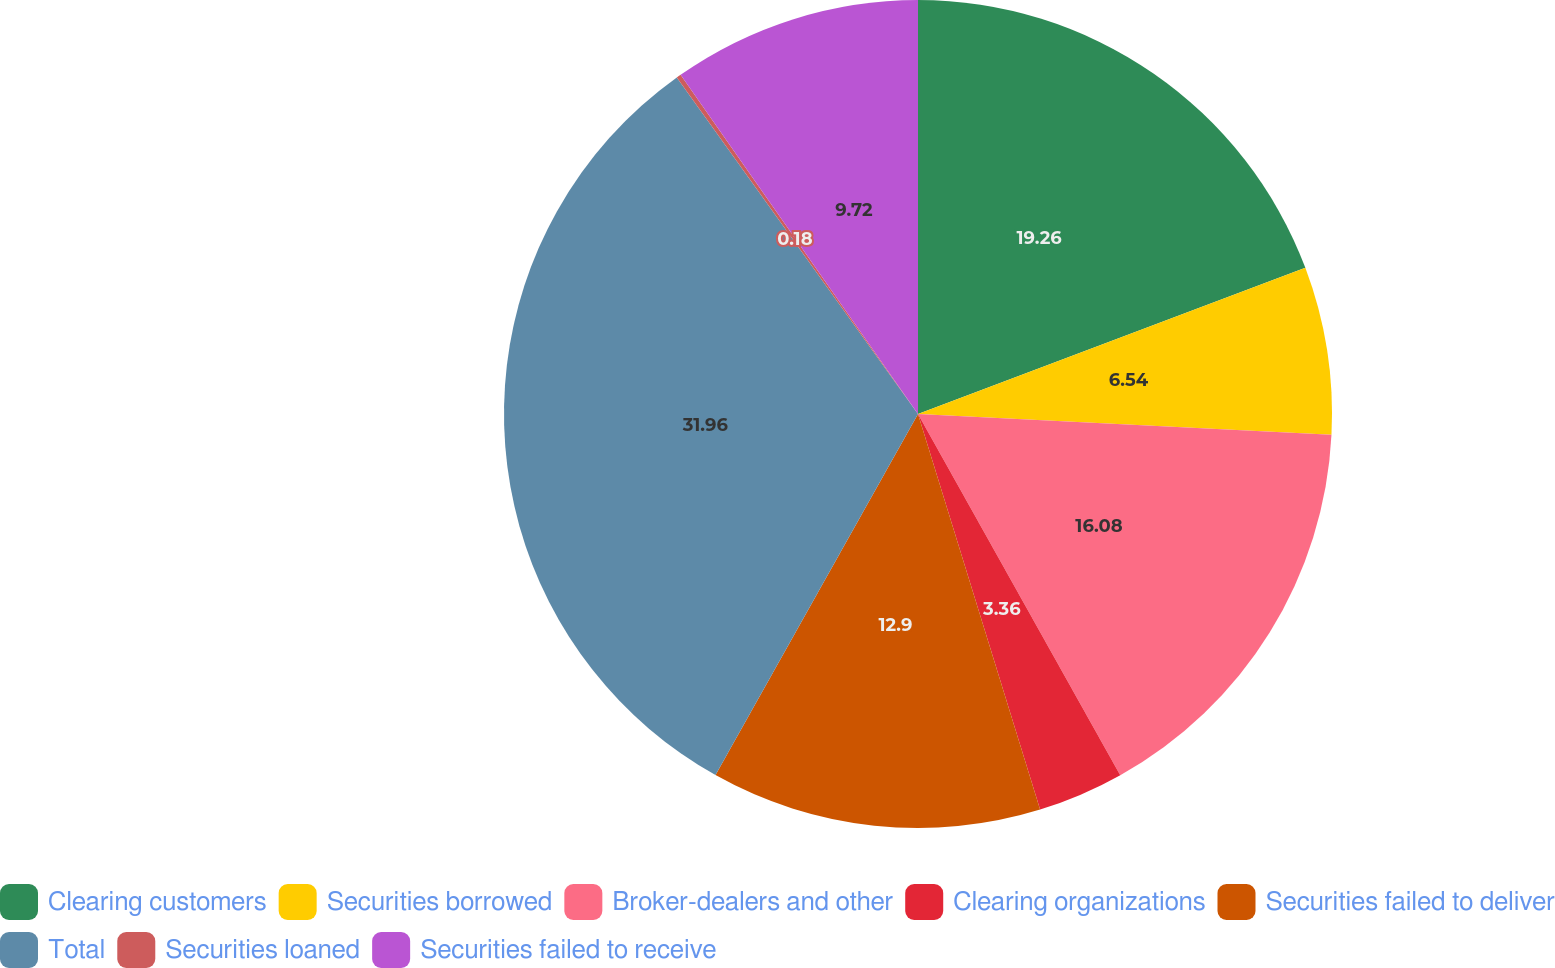Convert chart. <chart><loc_0><loc_0><loc_500><loc_500><pie_chart><fcel>Clearing customers<fcel>Securities borrowed<fcel>Broker-dealers and other<fcel>Clearing organizations<fcel>Securities failed to deliver<fcel>Total<fcel>Securities loaned<fcel>Securities failed to receive<nl><fcel>19.26%<fcel>6.54%<fcel>16.08%<fcel>3.36%<fcel>12.9%<fcel>31.97%<fcel>0.18%<fcel>9.72%<nl></chart> 